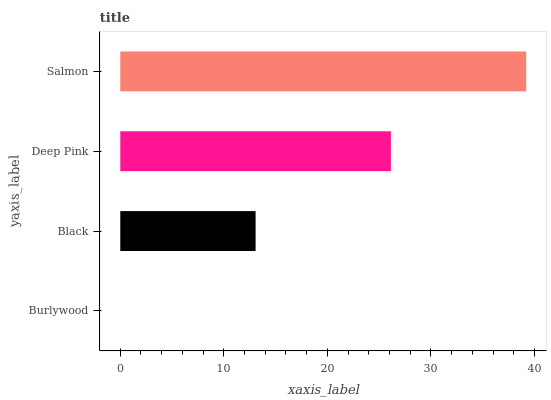Is Burlywood the minimum?
Answer yes or no. Yes. Is Salmon the maximum?
Answer yes or no. Yes. Is Black the minimum?
Answer yes or no. No. Is Black the maximum?
Answer yes or no. No. Is Black greater than Burlywood?
Answer yes or no. Yes. Is Burlywood less than Black?
Answer yes or no. Yes. Is Burlywood greater than Black?
Answer yes or no. No. Is Black less than Burlywood?
Answer yes or no. No. Is Deep Pink the high median?
Answer yes or no. Yes. Is Black the low median?
Answer yes or no. Yes. Is Burlywood the high median?
Answer yes or no. No. Is Deep Pink the low median?
Answer yes or no. No. 